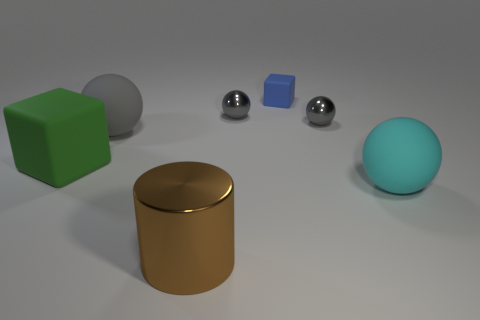What number of other things are the same color as the big shiny thing?
Your answer should be very brief. 0. How many big spheres are there?
Offer a very short reply. 2. What material is the small thing behind the gray metal object that is to the left of the small block?
Offer a terse response. Rubber. There is a brown thing that is the same size as the green cube; what is its material?
Your response must be concise. Metal. There is a rubber thing right of the blue matte object; does it have the same size as the metallic cylinder?
Your response must be concise. Yes. There is a tiny metallic object to the left of the small matte cube; is its shape the same as the large gray rubber object?
Ensure brevity in your answer.  Yes. How many objects are tiny spheres or gray balls that are on the right side of the large brown cylinder?
Provide a succinct answer. 2. Is the number of tiny red metal cylinders less than the number of blue rubber things?
Offer a terse response. Yes. Is the number of red shiny blocks greater than the number of small gray metal spheres?
Offer a very short reply. No. How many other objects are the same material as the brown cylinder?
Keep it short and to the point. 2. 